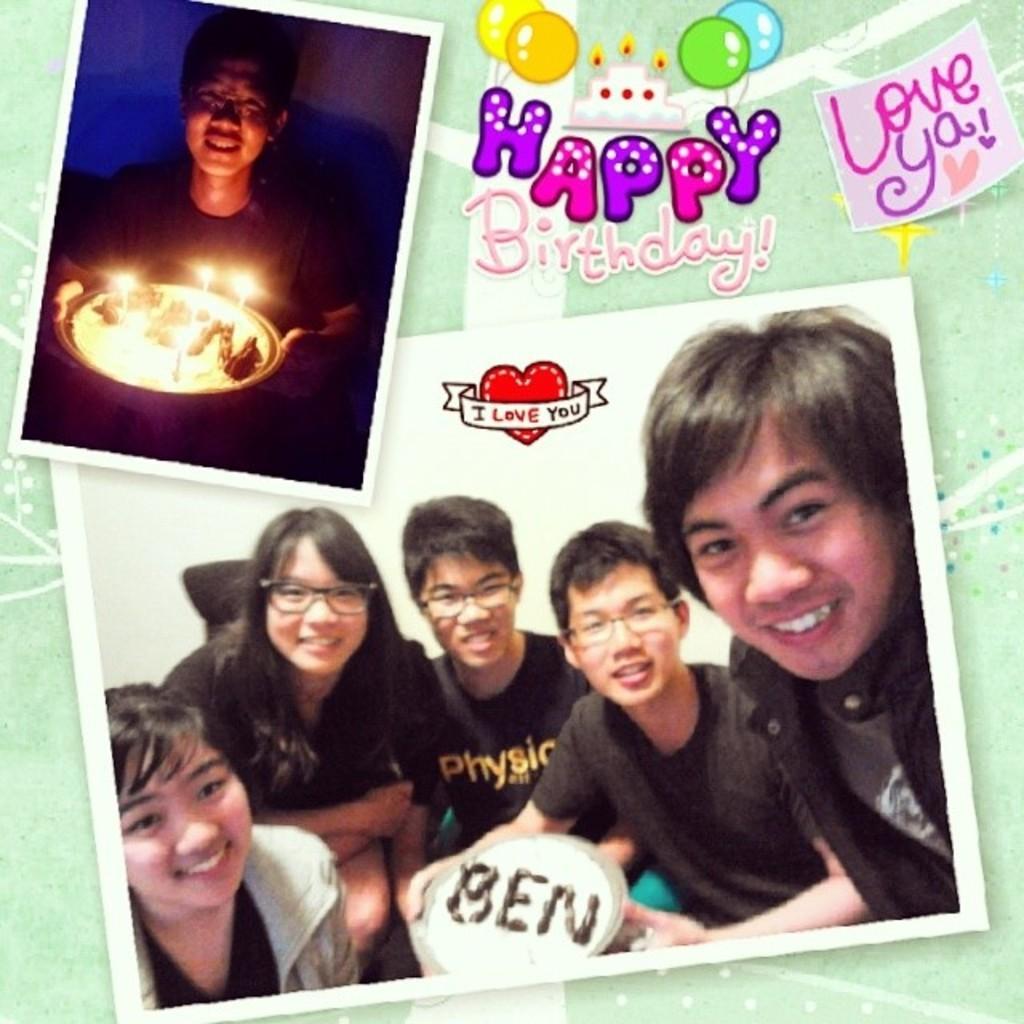Could you give a brief overview of what you see in this image? In this image we can see a collage of pictures. In one picture we can see a person holding a plate containing candles in it. In another image we can see group of people and in the background, we can see some text. 